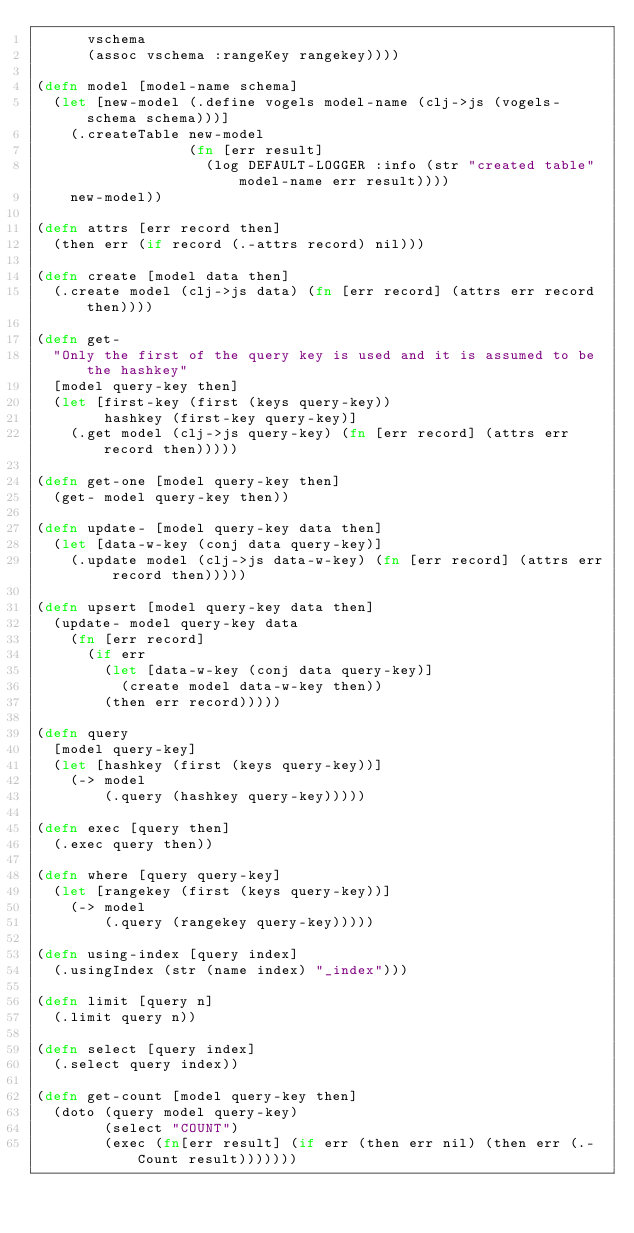Convert code to text. <code><loc_0><loc_0><loc_500><loc_500><_Clojure_>      vschema
      (assoc vschema :rangeKey rangekey))))

(defn model [model-name schema]
  (let [new-model (.define vogels model-name (clj->js (vogels-schema schema)))]
    (.createTable new-model
                  (fn [err result]
                    (log DEFAULT-LOGGER :info (str "created table" model-name err result))))
    new-model))

(defn attrs [err record then]
  (then err (if record (.-attrs record) nil)))

(defn create [model data then]
  (.create model (clj->js data) (fn [err record] (attrs err record then))))

(defn get-
  "Only the first of the query key is used and it is assumed to be the hashkey"
  [model query-key then]
  (let [first-key (first (keys query-key))
        hashkey (first-key query-key)]
    (.get model (clj->js query-key) (fn [err record] (attrs err record then)))))

(defn get-one [model query-key then]
  (get- model query-key then))

(defn update- [model query-key data then]
  (let [data-w-key (conj data query-key)]
    (.update model (clj->js data-w-key) (fn [err record] (attrs err record then)))))

(defn upsert [model query-key data then]
  (update- model query-key data
    (fn [err record]
      (if err
        (let [data-w-key (conj data query-key)]
          (create model data-w-key then))
        (then err record)))))

(defn query
  [model query-key]
  (let [hashkey (first (keys query-key))]
    (-> model
        (.query (hashkey query-key)))))

(defn exec [query then]
  (.exec query then))

(defn where [query query-key]
  (let [rangekey (first (keys query-key))]
    (-> model
        (.query (rangekey query-key)))))

(defn using-index [query index]
  (.usingIndex (str (name index) "_index")))

(defn limit [query n]
  (.limit query n))

(defn select [query index]
  (.select query index))

(defn get-count [model query-key then]
  (doto (query model query-key)
        (select "COUNT")
        (exec (fn[err result] (if err (then err nil) (then err (.-Count result)))))))
</code> 